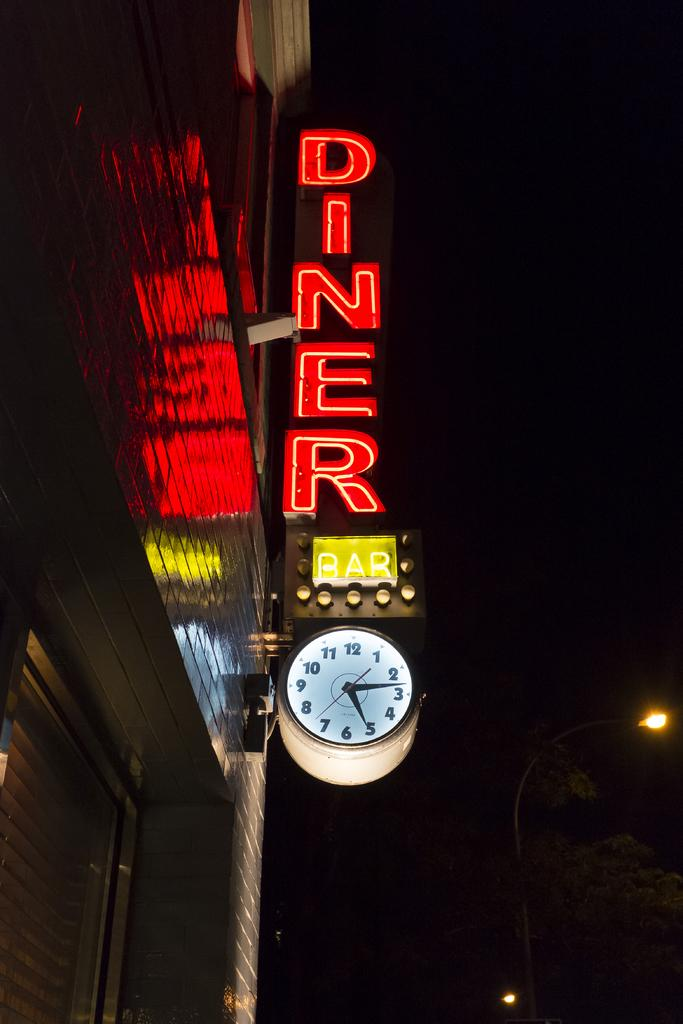<image>
Summarize the visual content of the image. A store front at night with a neon sign for DINER. 